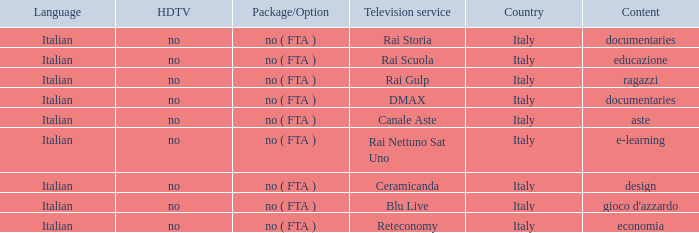What is the hdtv when documentaries are the subject matter? No, no. 